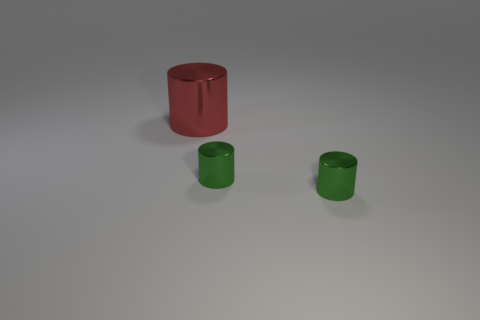Add 3 tiny purple matte cylinders. How many objects exist? 6 Subtract 0 blue cubes. How many objects are left? 3 Subtract all green metal objects. Subtract all large cylinders. How many objects are left? 0 Add 3 tiny green metal cylinders. How many tiny green metal cylinders are left? 5 Add 3 metallic things. How many metallic things exist? 6 